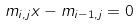Convert formula to latex. <formula><loc_0><loc_0><loc_500><loc_500>m _ { i , j } x - m _ { i - 1 , j } = 0</formula> 